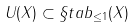<formula> <loc_0><loc_0><loc_500><loc_500>U ( X ) \subset \S t a b _ { \leq 1 } ( X )</formula> 